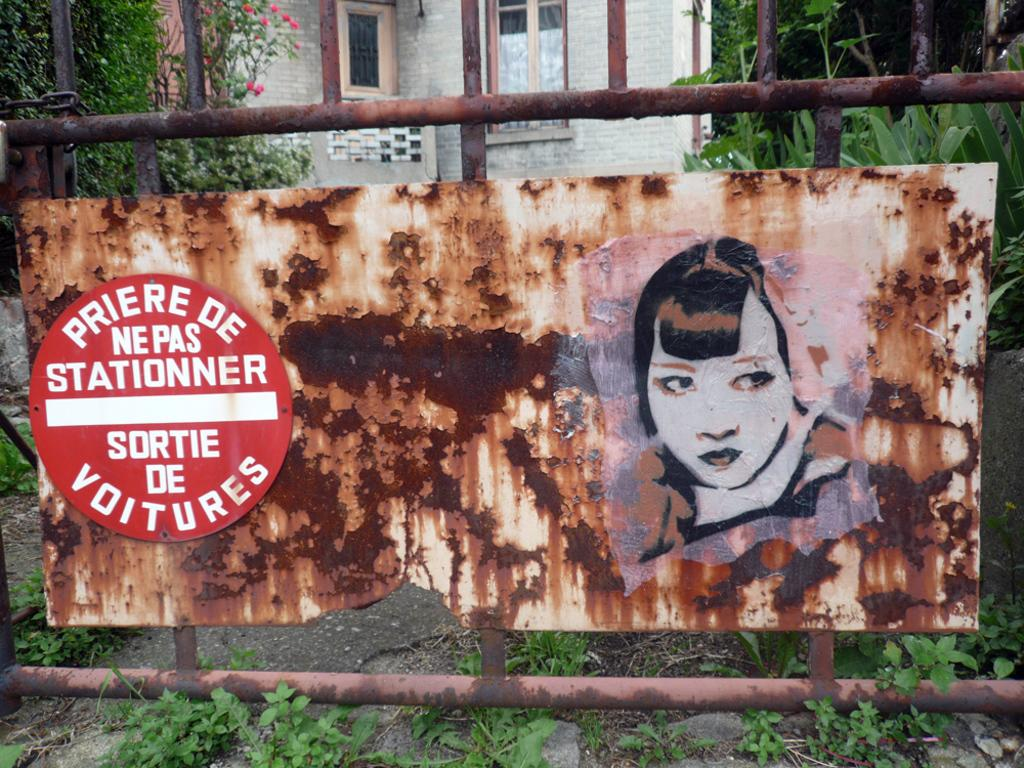What type of objects can be seen in the image? There are boards, a building, plants, trees, and other objects in the image. What is written on the board? Something is written on the board in the image. Can you describe the natural elements in the image? There are plants and trees in the image. What type of sweater is the tree wearing in the image? There are no sweaters present in the image, as trees do not wear clothing. 